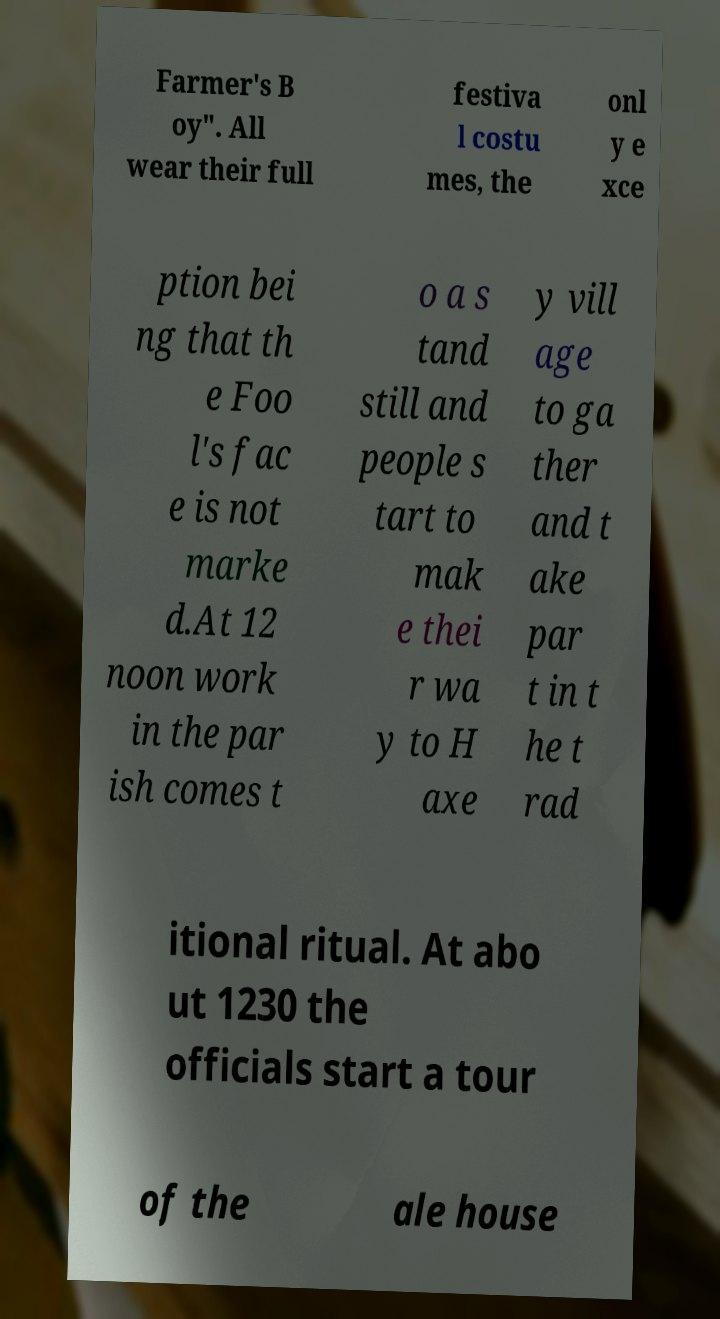Can you read and provide the text displayed in the image?This photo seems to have some interesting text. Can you extract and type it out for me? Farmer's B oy". All wear their full festiva l costu mes, the onl y e xce ption bei ng that th e Foo l's fac e is not marke d.At 12 noon work in the par ish comes t o a s tand still and people s tart to mak e thei r wa y to H axe y vill age to ga ther and t ake par t in t he t rad itional ritual. At abo ut 1230 the officials start a tour of the ale house 